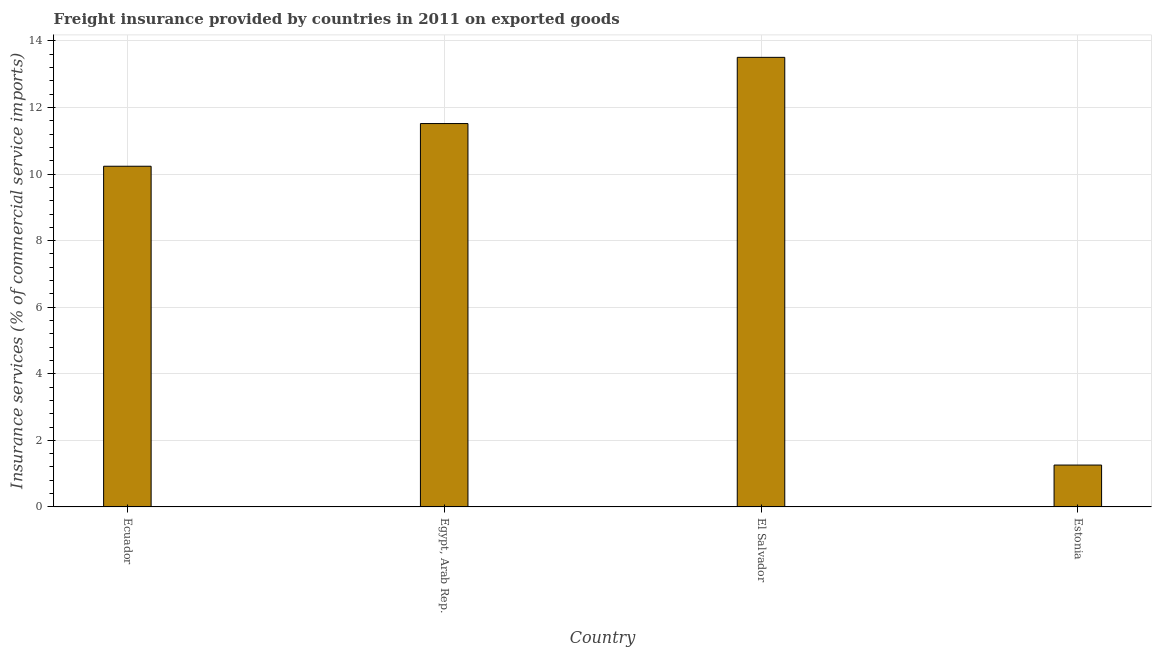Does the graph contain any zero values?
Provide a short and direct response. No. What is the title of the graph?
Keep it short and to the point. Freight insurance provided by countries in 2011 on exported goods . What is the label or title of the Y-axis?
Provide a short and direct response. Insurance services (% of commercial service imports). What is the freight insurance in El Salvador?
Your answer should be very brief. 13.51. Across all countries, what is the maximum freight insurance?
Provide a short and direct response. 13.51. Across all countries, what is the minimum freight insurance?
Give a very brief answer. 1.26. In which country was the freight insurance maximum?
Offer a very short reply. El Salvador. In which country was the freight insurance minimum?
Provide a short and direct response. Estonia. What is the sum of the freight insurance?
Your answer should be very brief. 36.52. What is the difference between the freight insurance in Egypt, Arab Rep. and El Salvador?
Ensure brevity in your answer.  -1.99. What is the average freight insurance per country?
Give a very brief answer. 9.13. What is the median freight insurance?
Keep it short and to the point. 10.88. What is the ratio of the freight insurance in El Salvador to that in Estonia?
Make the answer very short. 10.74. Is the freight insurance in El Salvador less than that in Estonia?
Your answer should be compact. No. What is the difference between the highest and the second highest freight insurance?
Offer a very short reply. 1.99. Is the sum of the freight insurance in Ecuador and Estonia greater than the maximum freight insurance across all countries?
Your answer should be very brief. No. What is the difference between the highest and the lowest freight insurance?
Make the answer very short. 12.25. How many bars are there?
Make the answer very short. 4. What is the difference between two consecutive major ticks on the Y-axis?
Keep it short and to the point. 2. Are the values on the major ticks of Y-axis written in scientific E-notation?
Offer a terse response. No. What is the Insurance services (% of commercial service imports) in Ecuador?
Your answer should be compact. 10.24. What is the Insurance services (% of commercial service imports) of Egypt, Arab Rep.?
Your response must be concise. 11.52. What is the Insurance services (% of commercial service imports) in El Salvador?
Make the answer very short. 13.51. What is the Insurance services (% of commercial service imports) of Estonia?
Ensure brevity in your answer.  1.26. What is the difference between the Insurance services (% of commercial service imports) in Ecuador and Egypt, Arab Rep.?
Offer a very short reply. -1.28. What is the difference between the Insurance services (% of commercial service imports) in Ecuador and El Salvador?
Your answer should be very brief. -3.27. What is the difference between the Insurance services (% of commercial service imports) in Ecuador and Estonia?
Offer a terse response. 8.98. What is the difference between the Insurance services (% of commercial service imports) in Egypt, Arab Rep. and El Salvador?
Your response must be concise. -1.99. What is the difference between the Insurance services (% of commercial service imports) in Egypt, Arab Rep. and Estonia?
Ensure brevity in your answer.  10.26. What is the difference between the Insurance services (% of commercial service imports) in El Salvador and Estonia?
Your answer should be very brief. 12.25. What is the ratio of the Insurance services (% of commercial service imports) in Ecuador to that in Egypt, Arab Rep.?
Make the answer very short. 0.89. What is the ratio of the Insurance services (% of commercial service imports) in Ecuador to that in El Salvador?
Provide a short and direct response. 0.76. What is the ratio of the Insurance services (% of commercial service imports) in Ecuador to that in Estonia?
Give a very brief answer. 8.14. What is the ratio of the Insurance services (% of commercial service imports) in Egypt, Arab Rep. to that in El Salvador?
Your answer should be compact. 0.85. What is the ratio of the Insurance services (% of commercial service imports) in Egypt, Arab Rep. to that in Estonia?
Offer a terse response. 9.16. What is the ratio of the Insurance services (% of commercial service imports) in El Salvador to that in Estonia?
Offer a terse response. 10.74. 